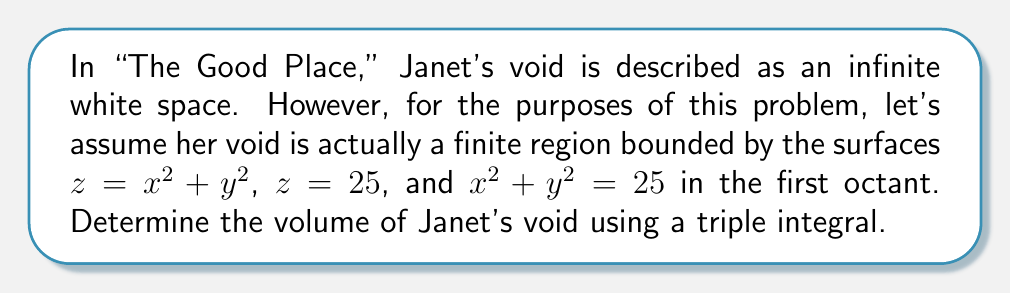Help me with this question. To solve this problem, we'll follow these steps:

1) First, we need to visualize the region. The void is bounded by a paraboloid ($z = x^2 + y^2$), a horizontal plane ($z = 25$), and a vertical cylinder ($x^2 + y^2 = 25$) in the first octant.

2) We'll use cylindrical coordinates for this integration:
   $x = r\cos\theta$
   $y = r\sin\theta$
   $z = z$

3) The limits of integration will be:
   $0 \leq \theta \leq \frac{\pi}{2}$ (first quadrant in xy-plane)
   $0 \leq r \leq 5$ (radius of the cylinder)
   $r^2 \leq z \leq 25$ (from the paraboloid to the top plane)

4) The volume integral in cylindrical coordinates is:
   $$V = \int_0^{\frac{\pi}{2}} \int_0^5 \int_{r^2}^{25} r \, dz \, dr \, d\theta$$

5) Let's solve the integral:
   $$V = \int_0^{\frac{\pi}{2}} \int_0^5 r(25 - r^2) \, dr \, d\theta$$
   $$= \int_0^{\frac{\pi}{2}} \left[25\frac{r^2}{2} - \frac{r^4}{4}\right]_0^5 \, d\theta$$
   $$= \int_0^{\frac{\pi}{2}} \left(312.5 - 156.25\right) \, d\theta$$
   $$= 156.25 \int_0^{\frac{\pi}{2}} \, d\theta$$
   $$= 156.25 \cdot \frac{\pi}{2}$$
   $$= 78.125\pi$$

6) Therefore, the volume of Janet's void is $78.125\pi$ cubic units.
Answer: $78.125\pi$ cubic units 